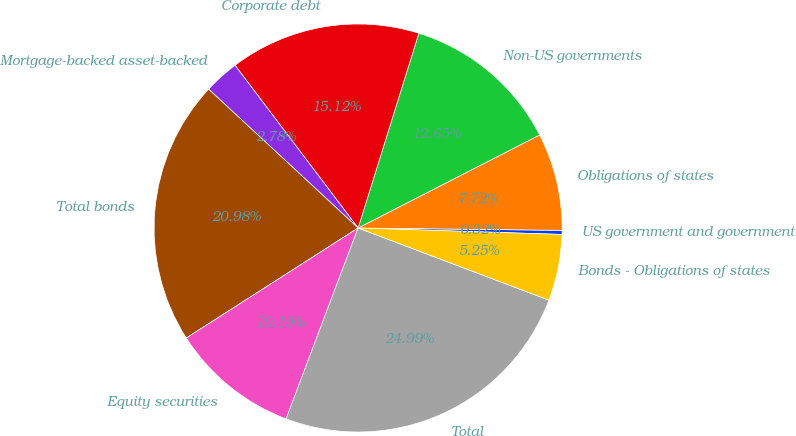<chart> <loc_0><loc_0><loc_500><loc_500><pie_chart><fcel>US government and government<fcel>Obligations of states<fcel>Non-US governments<fcel>Corporate debt<fcel>Mortgage-backed asset-backed<fcel>Total bonds<fcel>Equity securities<fcel>Total<fcel>Bonds - Obligations of states<nl><fcel>0.32%<fcel>7.72%<fcel>12.65%<fcel>15.12%<fcel>2.78%<fcel>20.98%<fcel>10.19%<fcel>24.99%<fcel>5.25%<nl></chart> 